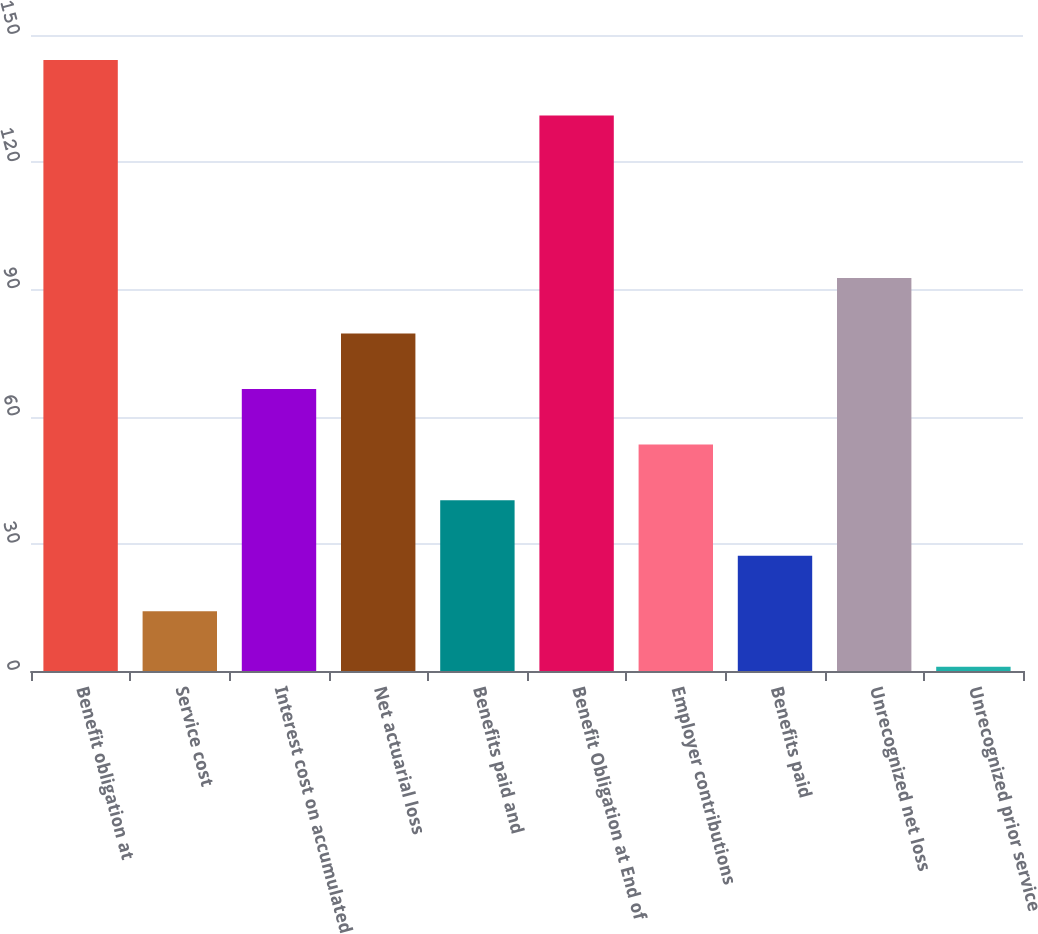<chart> <loc_0><loc_0><loc_500><loc_500><bar_chart><fcel>Benefit obligation at<fcel>Service cost<fcel>Interest cost on accumulated<fcel>Net actuarial loss<fcel>Benefits paid and<fcel>Benefit Obligation at End of<fcel>Employer contributions<fcel>Benefits paid<fcel>Unrecognized net loss<fcel>Unrecognized prior service<nl><fcel>144.1<fcel>14.1<fcel>66.5<fcel>79.6<fcel>40.3<fcel>131<fcel>53.4<fcel>27.2<fcel>92.7<fcel>1<nl></chart> 